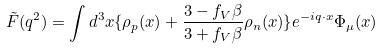<formula> <loc_0><loc_0><loc_500><loc_500>\tilde { F } ( q ^ { 2 } ) = \int d ^ { 3 } x \{ \rho _ { p } ( { x } ) + \frac { 3 - f _ { V } \beta } { 3 + f _ { V } \beta } \rho _ { n } ( { x } ) \} e ^ { - i { q } \cdot { x } } \Phi _ { \mu } ( { x } )</formula> 